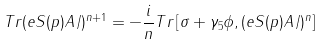<formula> <loc_0><loc_0><loc_500><loc_500>T r ( e S ( p ) A \, \slash ) ^ { n + 1 } = - { \frac { i } { n } } T r \left [ \sigma + \gamma _ { 5 } \phi , ( e S ( p ) A \, \slash ) ^ { n } \right ]</formula> 